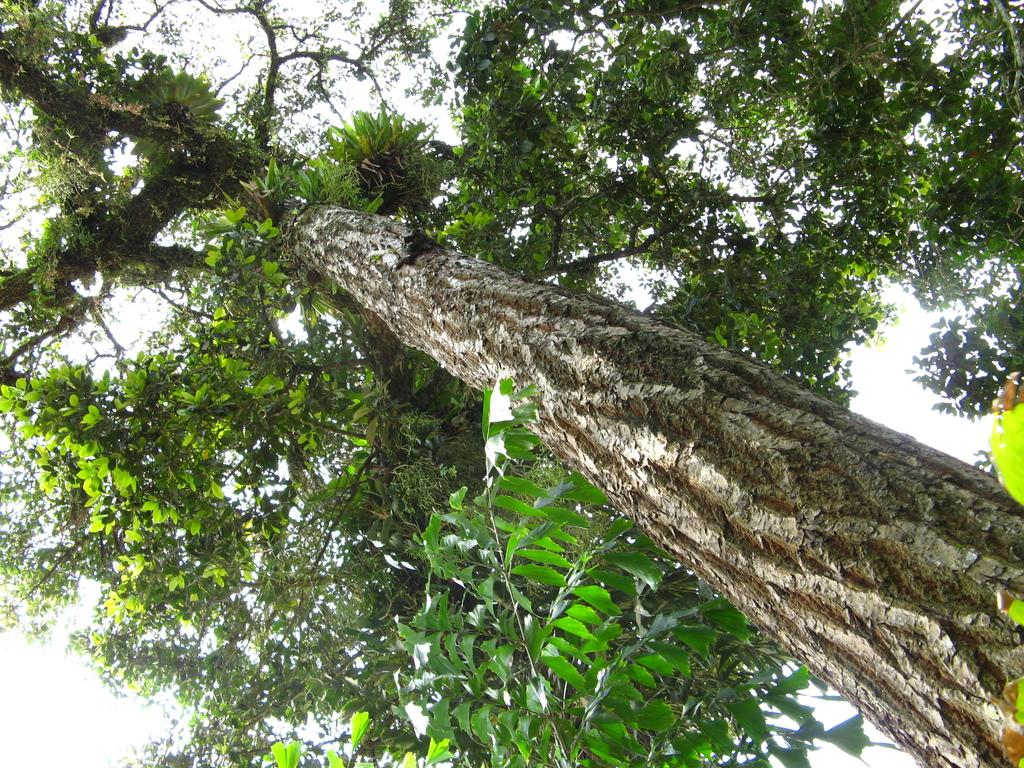What is located at the front of the image? There is a tree in the front of the image. What can be seen in the background of the image? The sky is visible in the background of the image. What type of knife is hanging from the tree in the image? There is no knife present in the image; it only features a tree and the sky in the background. 